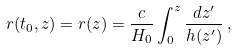Convert formula to latex. <formula><loc_0><loc_0><loc_500><loc_500>r ( t _ { 0 } , z ) = r ( z ) = \frac { c } { H _ { 0 } } \int _ { 0 } ^ { z } \frac { d z ^ { \prime } } { h ( z ^ { \prime } ) } \, ,</formula> 